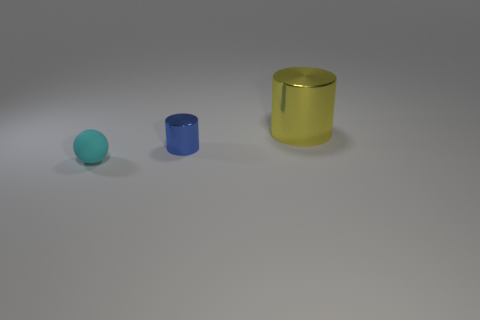Is there any other thing that is the same size as the yellow thing?
Give a very brief answer. No. What size is the yellow cylinder?
Your answer should be very brief. Large. There is a ball; is it the same size as the cylinder that is behind the small cylinder?
Provide a short and direct response. No. Is the size of the cyan matte thing the same as the yellow thing?
Ensure brevity in your answer.  No. What is the material of the big thing that is the same shape as the small metallic thing?
Keep it short and to the point. Metal. What number of rubber balls are the same size as the cyan object?
Your response must be concise. 0. What is the color of the other small cylinder that is the same material as the yellow cylinder?
Ensure brevity in your answer.  Blue. Are there fewer yellow metallic cylinders than brown cylinders?
Your answer should be very brief. No. How many cyan things are large cylinders or small spheres?
Give a very brief answer. 1. How many objects are both behind the cyan matte sphere and left of the yellow cylinder?
Ensure brevity in your answer.  1. 